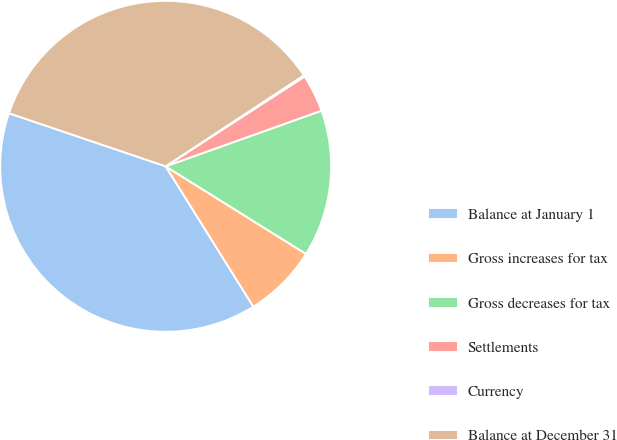<chart> <loc_0><loc_0><loc_500><loc_500><pie_chart><fcel>Balance at January 1<fcel>Gross increases for tax<fcel>Gross decreases for tax<fcel>Settlements<fcel>Currency<fcel>Balance at December 31<nl><fcel>39.09%<fcel>7.23%<fcel>14.34%<fcel>3.68%<fcel>0.13%<fcel>35.54%<nl></chart> 